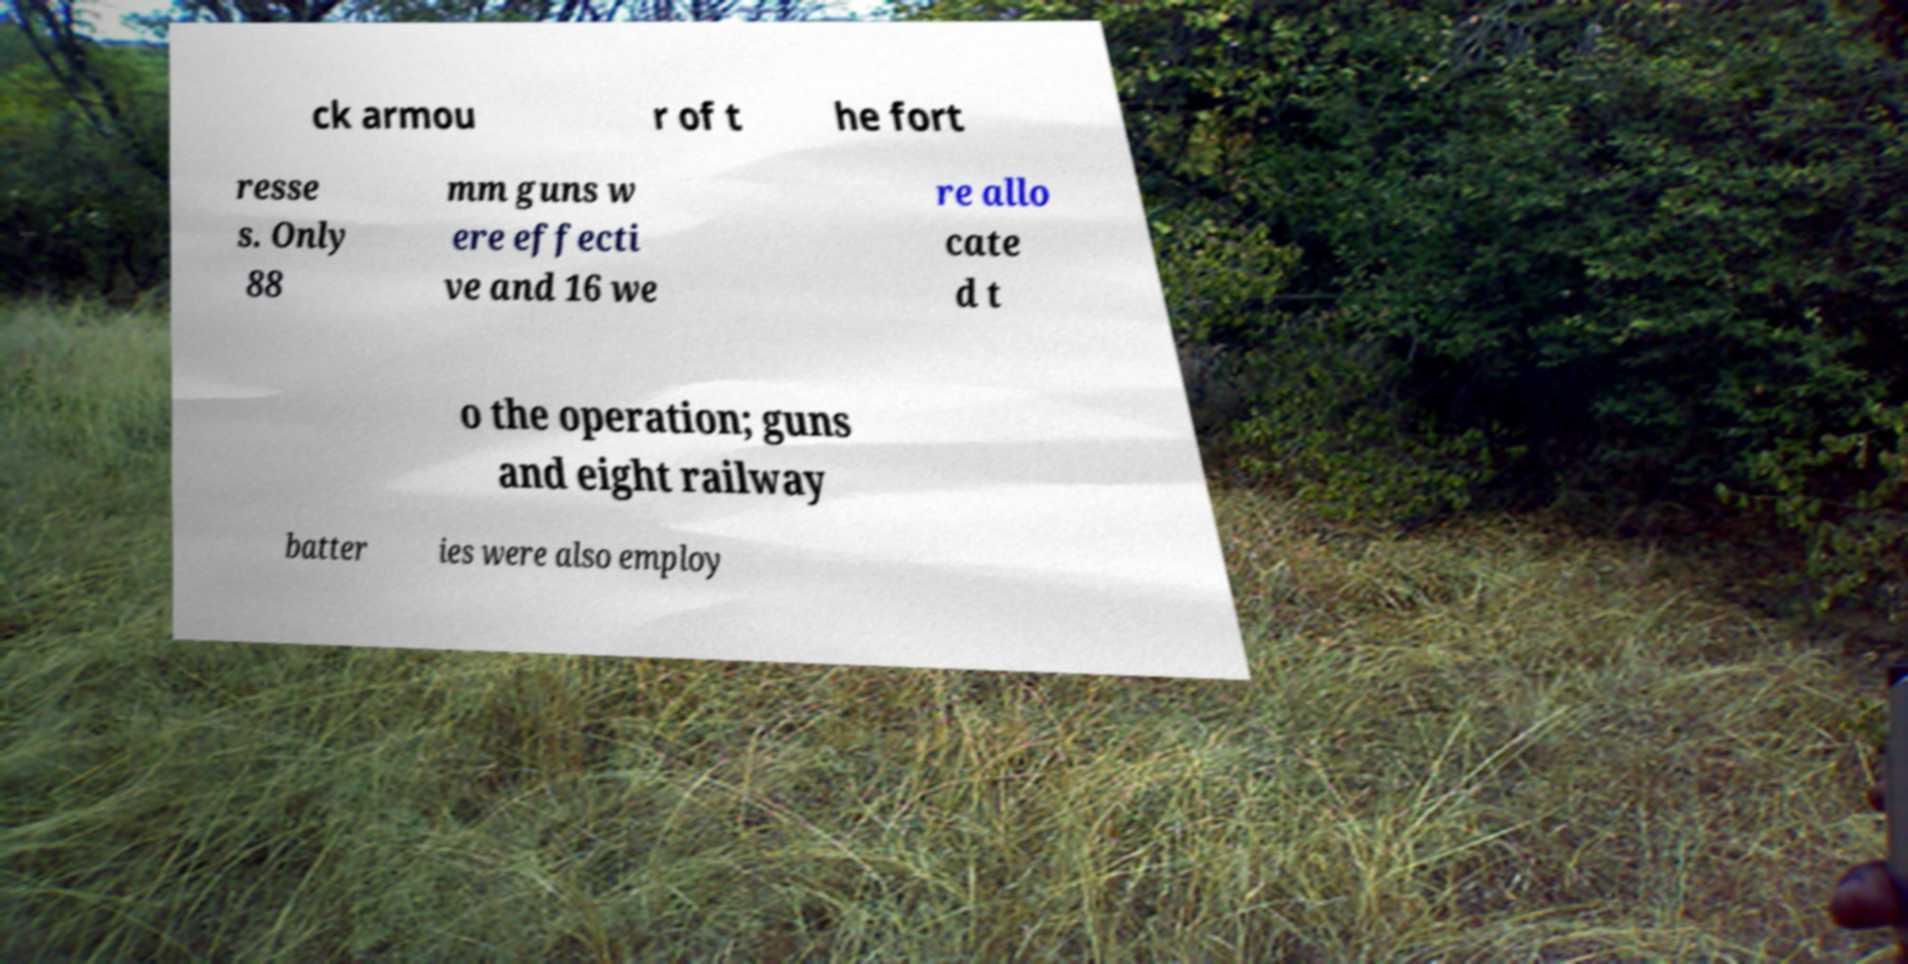Could you assist in decoding the text presented in this image and type it out clearly? ck armou r of t he fort resse s. Only 88 mm guns w ere effecti ve and 16 we re allo cate d t o the operation; guns and eight railway batter ies were also employ 